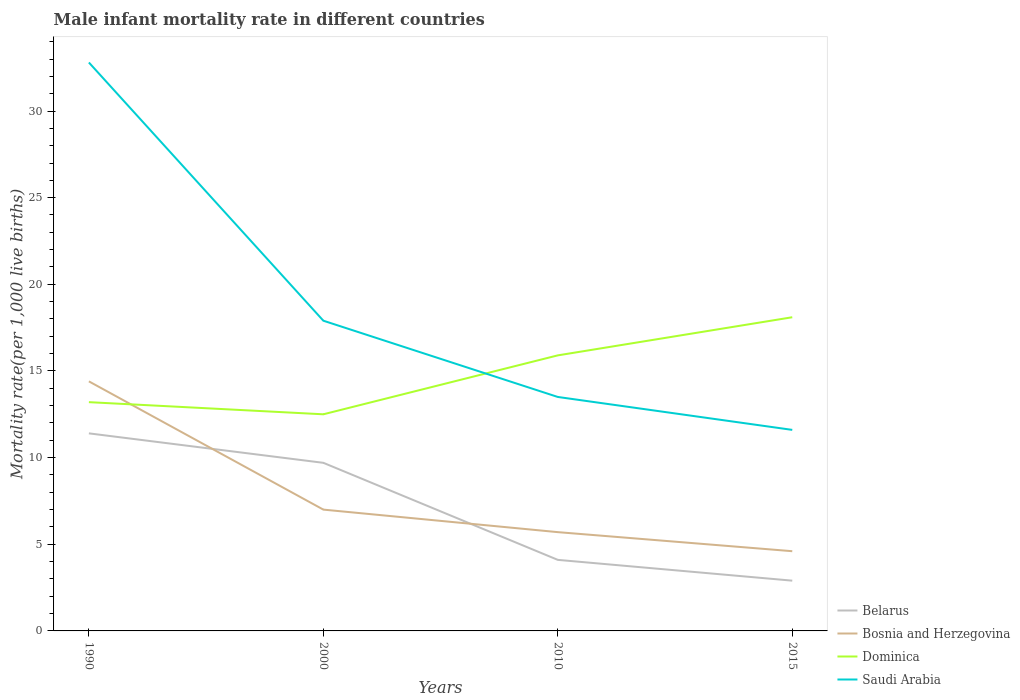How many different coloured lines are there?
Give a very brief answer. 4. Does the line corresponding to Saudi Arabia intersect with the line corresponding to Bosnia and Herzegovina?
Offer a terse response. No. Across all years, what is the maximum male infant mortality rate in Belarus?
Keep it short and to the point. 2.9. In which year was the male infant mortality rate in Belarus maximum?
Offer a very short reply. 2015. What is the total male infant mortality rate in Bosnia and Herzegovina in the graph?
Your answer should be compact. 1.1. What is the difference between the highest and the second highest male infant mortality rate in Belarus?
Give a very brief answer. 8.5. What is the difference between the highest and the lowest male infant mortality rate in Saudi Arabia?
Make the answer very short. 1. Is the male infant mortality rate in Bosnia and Herzegovina strictly greater than the male infant mortality rate in Saudi Arabia over the years?
Offer a terse response. Yes. How many lines are there?
Your answer should be compact. 4. Are the values on the major ticks of Y-axis written in scientific E-notation?
Provide a succinct answer. No. How are the legend labels stacked?
Offer a terse response. Vertical. What is the title of the graph?
Offer a terse response. Male infant mortality rate in different countries. Does "Serbia" appear as one of the legend labels in the graph?
Keep it short and to the point. No. What is the label or title of the X-axis?
Ensure brevity in your answer.  Years. What is the label or title of the Y-axis?
Make the answer very short. Mortality rate(per 1,0 live births). What is the Mortality rate(per 1,000 live births) of Belarus in 1990?
Your answer should be very brief. 11.4. What is the Mortality rate(per 1,000 live births) of Bosnia and Herzegovina in 1990?
Ensure brevity in your answer.  14.4. What is the Mortality rate(per 1,000 live births) of Dominica in 1990?
Make the answer very short. 13.2. What is the Mortality rate(per 1,000 live births) in Saudi Arabia in 1990?
Your response must be concise. 32.8. What is the Mortality rate(per 1,000 live births) of Belarus in 2000?
Your response must be concise. 9.7. What is the Mortality rate(per 1,000 live births) in Saudi Arabia in 2000?
Provide a short and direct response. 17.9. What is the Mortality rate(per 1,000 live births) of Belarus in 2010?
Offer a very short reply. 4.1. What is the Mortality rate(per 1,000 live births) of Bosnia and Herzegovina in 2010?
Keep it short and to the point. 5.7. What is the Mortality rate(per 1,000 live births) of Belarus in 2015?
Provide a short and direct response. 2.9. What is the Mortality rate(per 1,000 live births) of Bosnia and Herzegovina in 2015?
Offer a terse response. 4.6. What is the Mortality rate(per 1,000 live births) of Dominica in 2015?
Give a very brief answer. 18.1. Across all years, what is the maximum Mortality rate(per 1,000 live births) of Saudi Arabia?
Offer a very short reply. 32.8. Across all years, what is the minimum Mortality rate(per 1,000 live births) of Saudi Arabia?
Your answer should be compact. 11.6. What is the total Mortality rate(per 1,000 live births) in Belarus in the graph?
Your answer should be compact. 28.1. What is the total Mortality rate(per 1,000 live births) of Bosnia and Herzegovina in the graph?
Offer a terse response. 31.7. What is the total Mortality rate(per 1,000 live births) of Dominica in the graph?
Provide a short and direct response. 59.7. What is the total Mortality rate(per 1,000 live births) in Saudi Arabia in the graph?
Give a very brief answer. 75.8. What is the difference between the Mortality rate(per 1,000 live births) in Belarus in 1990 and that in 2000?
Keep it short and to the point. 1.7. What is the difference between the Mortality rate(per 1,000 live births) in Bosnia and Herzegovina in 1990 and that in 2000?
Keep it short and to the point. 7.4. What is the difference between the Mortality rate(per 1,000 live births) in Dominica in 1990 and that in 2000?
Offer a very short reply. 0.7. What is the difference between the Mortality rate(per 1,000 live births) in Belarus in 1990 and that in 2010?
Your answer should be very brief. 7.3. What is the difference between the Mortality rate(per 1,000 live births) of Dominica in 1990 and that in 2010?
Offer a terse response. -2.7. What is the difference between the Mortality rate(per 1,000 live births) in Saudi Arabia in 1990 and that in 2010?
Your answer should be compact. 19.3. What is the difference between the Mortality rate(per 1,000 live births) of Belarus in 1990 and that in 2015?
Provide a succinct answer. 8.5. What is the difference between the Mortality rate(per 1,000 live births) of Bosnia and Herzegovina in 1990 and that in 2015?
Offer a terse response. 9.8. What is the difference between the Mortality rate(per 1,000 live births) of Saudi Arabia in 1990 and that in 2015?
Make the answer very short. 21.2. What is the difference between the Mortality rate(per 1,000 live births) in Belarus in 2000 and that in 2010?
Keep it short and to the point. 5.6. What is the difference between the Mortality rate(per 1,000 live births) in Bosnia and Herzegovina in 2000 and that in 2010?
Keep it short and to the point. 1.3. What is the difference between the Mortality rate(per 1,000 live births) of Dominica in 2000 and that in 2010?
Give a very brief answer. -3.4. What is the difference between the Mortality rate(per 1,000 live births) in Bosnia and Herzegovina in 2000 and that in 2015?
Provide a short and direct response. 2.4. What is the difference between the Mortality rate(per 1,000 live births) of Saudi Arabia in 2000 and that in 2015?
Keep it short and to the point. 6.3. What is the difference between the Mortality rate(per 1,000 live births) in Belarus in 2010 and that in 2015?
Provide a succinct answer. 1.2. What is the difference between the Mortality rate(per 1,000 live births) of Bosnia and Herzegovina in 2010 and that in 2015?
Provide a succinct answer. 1.1. What is the difference between the Mortality rate(per 1,000 live births) of Dominica in 2010 and that in 2015?
Make the answer very short. -2.2. What is the difference between the Mortality rate(per 1,000 live births) in Belarus in 1990 and the Mortality rate(per 1,000 live births) in Bosnia and Herzegovina in 2000?
Provide a short and direct response. 4.4. What is the difference between the Mortality rate(per 1,000 live births) of Dominica in 1990 and the Mortality rate(per 1,000 live births) of Saudi Arabia in 2000?
Give a very brief answer. -4.7. What is the difference between the Mortality rate(per 1,000 live births) of Belarus in 1990 and the Mortality rate(per 1,000 live births) of Bosnia and Herzegovina in 2010?
Give a very brief answer. 5.7. What is the difference between the Mortality rate(per 1,000 live births) in Belarus in 1990 and the Mortality rate(per 1,000 live births) in Dominica in 2010?
Your answer should be compact. -4.5. What is the difference between the Mortality rate(per 1,000 live births) of Belarus in 1990 and the Mortality rate(per 1,000 live births) of Saudi Arabia in 2010?
Give a very brief answer. -2.1. What is the difference between the Mortality rate(per 1,000 live births) of Bosnia and Herzegovina in 1990 and the Mortality rate(per 1,000 live births) of Dominica in 2010?
Your response must be concise. -1.5. What is the difference between the Mortality rate(per 1,000 live births) of Bosnia and Herzegovina in 1990 and the Mortality rate(per 1,000 live births) of Saudi Arabia in 2010?
Your answer should be very brief. 0.9. What is the difference between the Mortality rate(per 1,000 live births) in Belarus in 1990 and the Mortality rate(per 1,000 live births) in Bosnia and Herzegovina in 2015?
Your answer should be compact. 6.8. What is the difference between the Mortality rate(per 1,000 live births) of Belarus in 1990 and the Mortality rate(per 1,000 live births) of Dominica in 2015?
Offer a terse response. -6.7. What is the difference between the Mortality rate(per 1,000 live births) of Dominica in 1990 and the Mortality rate(per 1,000 live births) of Saudi Arabia in 2015?
Your answer should be very brief. 1.6. What is the difference between the Mortality rate(per 1,000 live births) of Bosnia and Herzegovina in 2000 and the Mortality rate(per 1,000 live births) of Saudi Arabia in 2010?
Your answer should be very brief. -6.5. What is the difference between the Mortality rate(per 1,000 live births) of Dominica in 2000 and the Mortality rate(per 1,000 live births) of Saudi Arabia in 2010?
Your answer should be very brief. -1. What is the difference between the Mortality rate(per 1,000 live births) of Belarus in 2000 and the Mortality rate(per 1,000 live births) of Bosnia and Herzegovina in 2015?
Offer a terse response. 5.1. What is the difference between the Mortality rate(per 1,000 live births) of Belarus in 2000 and the Mortality rate(per 1,000 live births) of Dominica in 2015?
Provide a short and direct response. -8.4. What is the difference between the Mortality rate(per 1,000 live births) of Dominica in 2000 and the Mortality rate(per 1,000 live births) of Saudi Arabia in 2015?
Provide a short and direct response. 0.9. What is the difference between the Mortality rate(per 1,000 live births) in Belarus in 2010 and the Mortality rate(per 1,000 live births) in Saudi Arabia in 2015?
Make the answer very short. -7.5. What is the difference between the Mortality rate(per 1,000 live births) in Bosnia and Herzegovina in 2010 and the Mortality rate(per 1,000 live births) in Saudi Arabia in 2015?
Your answer should be compact. -5.9. What is the average Mortality rate(per 1,000 live births) of Belarus per year?
Provide a short and direct response. 7.03. What is the average Mortality rate(per 1,000 live births) of Bosnia and Herzegovina per year?
Provide a short and direct response. 7.92. What is the average Mortality rate(per 1,000 live births) of Dominica per year?
Make the answer very short. 14.93. What is the average Mortality rate(per 1,000 live births) in Saudi Arabia per year?
Your response must be concise. 18.95. In the year 1990, what is the difference between the Mortality rate(per 1,000 live births) in Belarus and Mortality rate(per 1,000 live births) in Bosnia and Herzegovina?
Offer a very short reply. -3. In the year 1990, what is the difference between the Mortality rate(per 1,000 live births) in Belarus and Mortality rate(per 1,000 live births) in Saudi Arabia?
Offer a very short reply. -21.4. In the year 1990, what is the difference between the Mortality rate(per 1,000 live births) in Bosnia and Herzegovina and Mortality rate(per 1,000 live births) in Dominica?
Your response must be concise. 1.2. In the year 1990, what is the difference between the Mortality rate(per 1,000 live births) of Bosnia and Herzegovina and Mortality rate(per 1,000 live births) of Saudi Arabia?
Provide a short and direct response. -18.4. In the year 1990, what is the difference between the Mortality rate(per 1,000 live births) in Dominica and Mortality rate(per 1,000 live births) in Saudi Arabia?
Keep it short and to the point. -19.6. In the year 2000, what is the difference between the Mortality rate(per 1,000 live births) of Belarus and Mortality rate(per 1,000 live births) of Dominica?
Your answer should be compact. -2.8. In the year 2000, what is the difference between the Mortality rate(per 1,000 live births) in Belarus and Mortality rate(per 1,000 live births) in Saudi Arabia?
Ensure brevity in your answer.  -8.2. In the year 2010, what is the difference between the Mortality rate(per 1,000 live births) of Belarus and Mortality rate(per 1,000 live births) of Dominica?
Your answer should be compact. -11.8. In the year 2010, what is the difference between the Mortality rate(per 1,000 live births) of Bosnia and Herzegovina and Mortality rate(per 1,000 live births) of Dominica?
Offer a terse response. -10.2. In the year 2010, what is the difference between the Mortality rate(per 1,000 live births) of Bosnia and Herzegovina and Mortality rate(per 1,000 live births) of Saudi Arabia?
Make the answer very short. -7.8. In the year 2010, what is the difference between the Mortality rate(per 1,000 live births) in Dominica and Mortality rate(per 1,000 live births) in Saudi Arabia?
Your answer should be very brief. 2.4. In the year 2015, what is the difference between the Mortality rate(per 1,000 live births) of Belarus and Mortality rate(per 1,000 live births) of Dominica?
Your answer should be very brief. -15.2. In the year 2015, what is the difference between the Mortality rate(per 1,000 live births) in Belarus and Mortality rate(per 1,000 live births) in Saudi Arabia?
Give a very brief answer. -8.7. In the year 2015, what is the difference between the Mortality rate(per 1,000 live births) in Bosnia and Herzegovina and Mortality rate(per 1,000 live births) in Dominica?
Give a very brief answer. -13.5. In the year 2015, what is the difference between the Mortality rate(per 1,000 live births) of Bosnia and Herzegovina and Mortality rate(per 1,000 live births) of Saudi Arabia?
Give a very brief answer. -7. In the year 2015, what is the difference between the Mortality rate(per 1,000 live births) in Dominica and Mortality rate(per 1,000 live births) in Saudi Arabia?
Provide a succinct answer. 6.5. What is the ratio of the Mortality rate(per 1,000 live births) in Belarus in 1990 to that in 2000?
Ensure brevity in your answer.  1.18. What is the ratio of the Mortality rate(per 1,000 live births) in Bosnia and Herzegovina in 1990 to that in 2000?
Offer a very short reply. 2.06. What is the ratio of the Mortality rate(per 1,000 live births) of Dominica in 1990 to that in 2000?
Your answer should be very brief. 1.06. What is the ratio of the Mortality rate(per 1,000 live births) of Saudi Arabia in 1990 to that in 2000?
Offer a very short reply. 1.83. What is the ratio of the Mortality rate(per 1,000 live births) of Belarus in 1990 to that in 2010?
Make the answer very short. 2.78. What is the ratio of the Mortality rate(per 1,000 live births) in Bosnia and Herzegovina in 1990 to that in 2010?
Provide a succinct answer. 2.53. What is the ratio of the Mortality rate(per 1,000 live births) in Dominica in 1990 to that in 2010?
Your answer should be compact. 0.83. What is the ratio of the Mortality rate(per 1,000 live births) in Saudi Arabia in 1990 to that in 2010?
Offer a very short reply. 2.43. What is the ratio of the Mortality rate(per 1,000 live births) in Belarus in 1990 to that in 2015?
Ensure brevity in your answer.  3.93. What is the ratio of the Mortality rate(per 1,000 live births) in Bosnia and Herzegovina in 1990 to that in 2015?
Make the answer very short. 3.13. What is the ratio of the Mortality rate(per 1,000 live births) in Dominica in 1990 to that in 2015?
Keep it short and to the point. 0.73. What is the ratio of the Mortality rate(per 1,000 live births) of Saudi Arabia in 1990 to that in 2015?
Offer a very short reply. 2.83. What is the ratio of the Mortality rate(per 1,000 live births) of Belarus in 2000 to that in 2010?
Provide a succinct answer. 2.37. What is the ratio of the Mortality rate(per 1,000 live births) in Bosnia and Herzegovina in 2000 to that in 2010?
Your answer should be very brief. 1.23. What is the ratio of the Mortality rate(per 1,000 live births) of Dominica in 2000 to that in 2010?
Your response must be concise. 0.79. What is the ratio of the Mortality rate(per 1,000 live births) of Saudi Arabia in 2000 to that in 2010?
Your answer should be compact. 1.33. What is the ratio of the Mortality rate(per 1,000 live births) of Belarus in 2000 to that in 2015?
Offer a terse response. 3.34. What is the ratio of the Mortality rate(per 1,000 live births) of Bosnia and Herzegovina in 2000 to that in 2015?
Give a very brief answer. 1.52. What is the ratio of the Mortality rate(per 1,000 live births) in Dominica in 2000 to that in 2015?
Offer a terse response. 0.69. What is the ratio of the Mortality rate(per 1,000 live births) in Saudi Arabia in 2000 to that in 2015?
Offer a terse response. 1.54. What is the ratio of the Mortality rate(per 1,000 live births) in Belarus in 2010 to that in 2015?
Your answer should be very brief. 1.41. What is the ratio of the Mortality rate(per 1,000 live births) of Bosnia and Herzegovina in 2010 to that in 2015?
Offer a terse response. 1.24. What is the ratio of the Mortality rate(per 1,000 live births) of Dominica in 2010 to that in 2015?
Make the answer very short. 0.88. What is the ratio of the Mortality rate(per 1,000 live births) of Saudi Arabia in 2010 to that in 2015?
Offer a terse response. 1.16. What is the difference between the highest and the second highest Mortality rate(per 1,000 live births) of Belarus?
Ensure brevity in your answer.  1.7. What is the difference between the highest and the second highest Mortality rate(per 1,000 live births) in Dominica?
Offer a terse response. 2.2. What is the difference between the highest and the lowest Mortality rate(per 1,000 live births) of Bosnia and Herzegovina?
Offer a very short reply. 9.8. What is the difference between the highest and the lowest Mortality rate(per 1,000 live births) of Saudi Arabia?
Give a very brief answer. 21.2. 